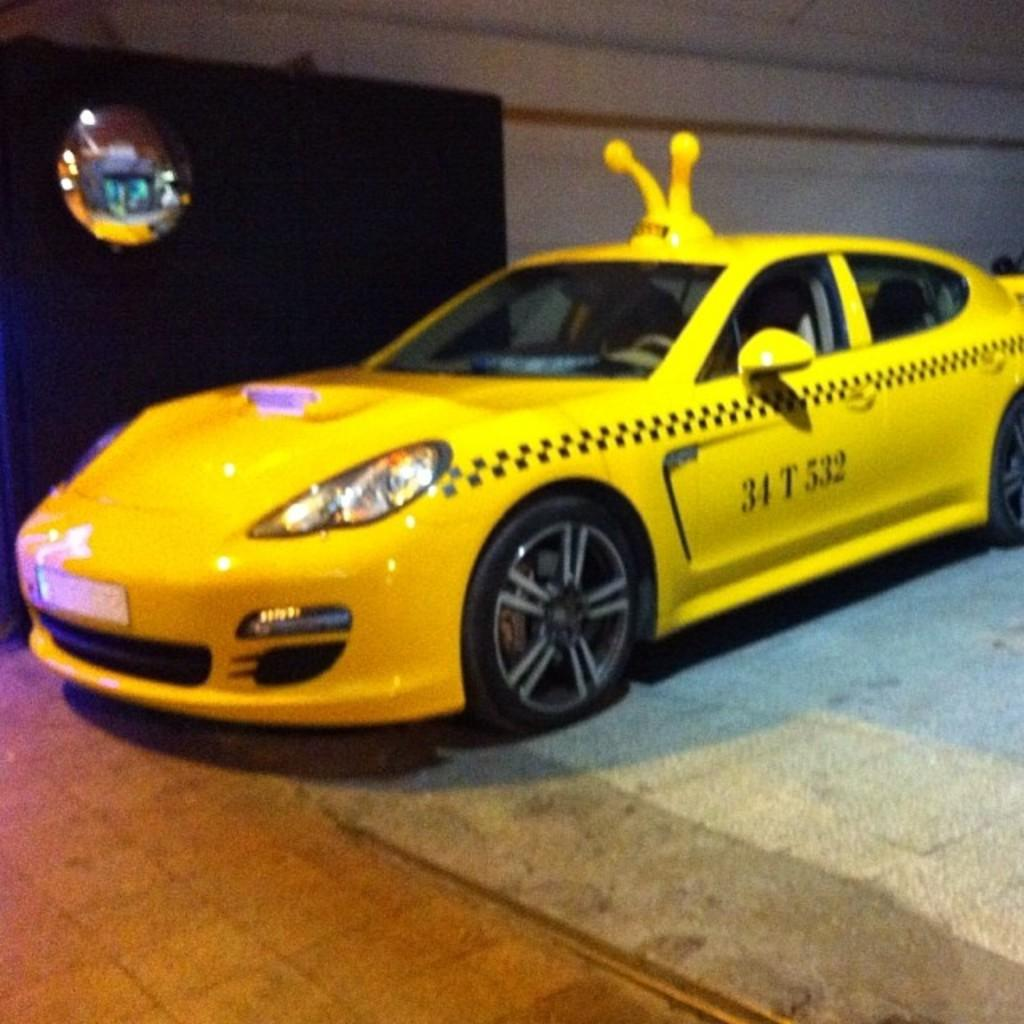<image>
Offer a succinct explanation of the picture presented. a yellow car numbered 34t532 on the driver sidedoor 